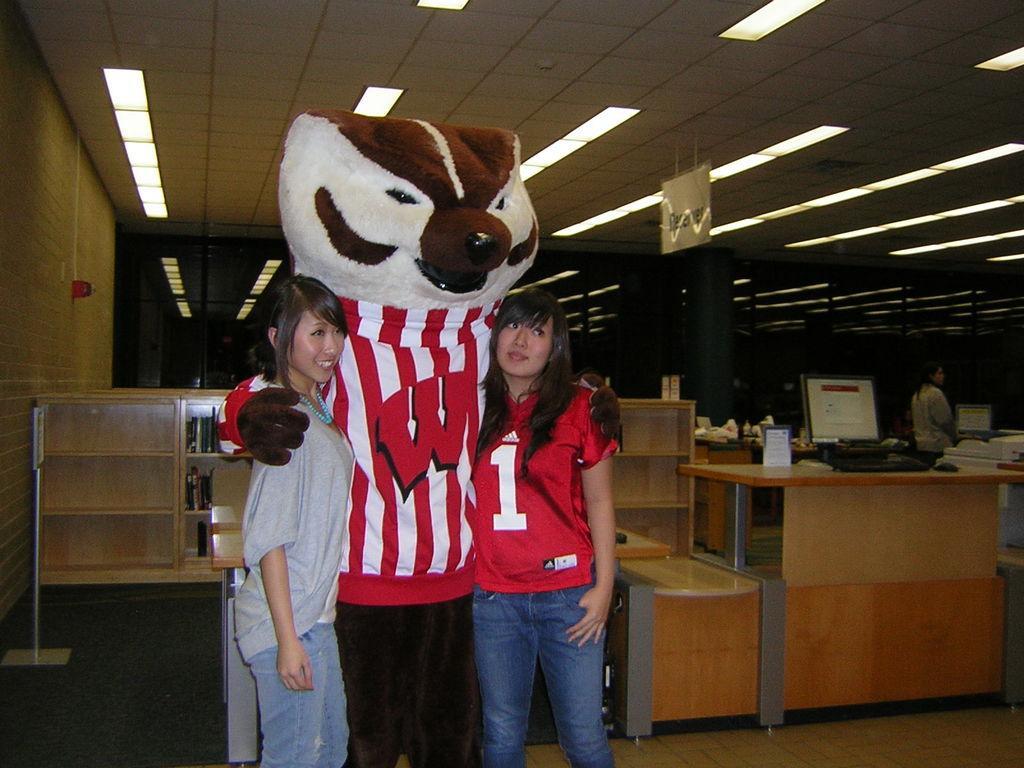Describe this image in one or two sentences. Here we can see a mascot and two women are standing on the floor. There are tables, racks, books, monitors, keyboard, mouse, and few objects. Here we can see a person. In the background we can see lights, ceiling, and wall. 